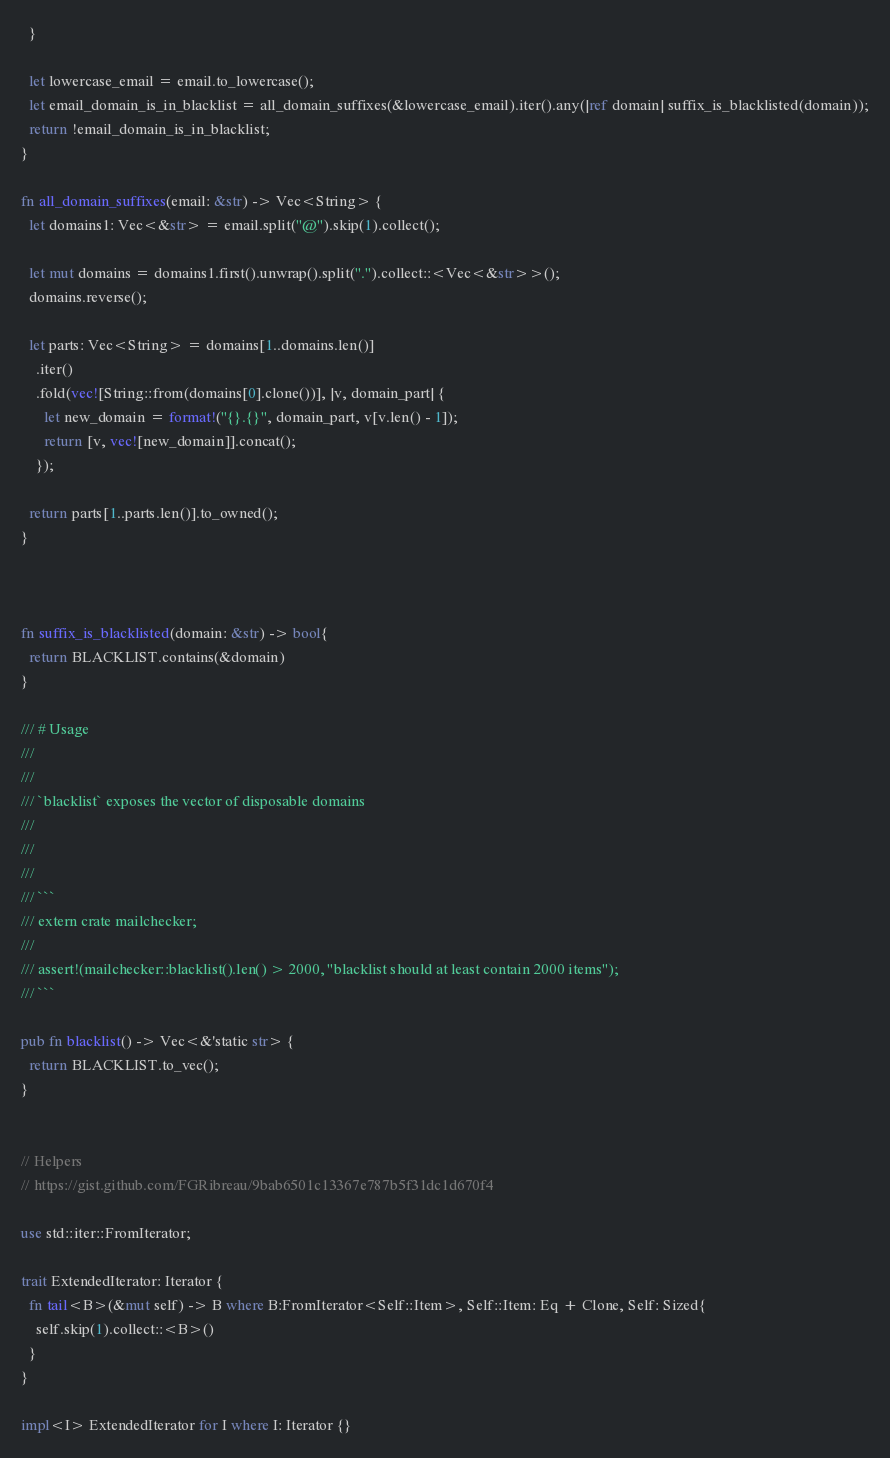<code> <loc_0><loc_0><loc_500><loc_500><_Rust_>  }

  let lowercase_email = email.to_lowercase();
  let email_domain_is_in_blacklist = all_domain_suffixes(&lowercase_email).iter().any(|ref domain| suffix_is_blacklisted(domain));
  return !email_domain_is_in_blacklist;
}

fn all_domain_suffixes(email: &str) -> Vec<String> {
  let domains1: Vec<&str> = email.split("@").skip(1).collect();

  let mut domains = domains1.first().unwrap().split(".").collect::<Vec<&str>>();
  domains.reverse();

  let parts: Vec<String> = domains[1..domains.len()]
    .iter()
    .fold(vec![String::from(domains[0].clone())], |v, domain_part| {
      let new_domain = format!("{}.{}", domain_part, v[v.len() - 1]);
      return [v, vec![new_domain]].concat();
    });

  return parts[1..parts.len()].to_owned();
}



fn suffix_is_blacklisted(domain: &str) -> bool{
  return BLACKLIST.contains(&domain)
}

/// # Usage
///
///
/// `blacklist` exposes the vector of disposable domains
///
///
///
/// ```
/// extern crate mailchecker;
///
/// assert!(mailchecker::blacklist().len() > 2000, "blacklist should at least contain 2000 items");
/// ```

pub fn blacklist() -> Vec<&'static str> {
  return BLACKLIST.to_vec();
}


// Helpers
// https://gist.github.com/FGRibreau/9bab6501c13367e787b5f31dc1d670f4

use std::iter::FromIterator;

trait ExtendedIterator: Iterator {
  fn tail<B>(&mut self) -> B where B:FromIterator<Self::Item>, Self::Item: Eq + Clone, Self: Sized{
    self.skip(1).collect::<B>()
  }
}

impl<I> ExtendedIterator for I where I: Iterator {}
</code> 